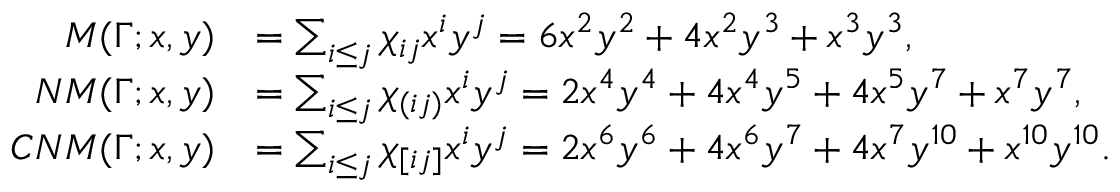<formula> <loc_0><loc_0><loc_500><loc_500>\begin{array} { r l } { M ( \Gamma ; x , y ) } & { = \sum _ { i \leq j } \chi _ { i j } x ^ { i } y ^ { j } = 6 x ^ { 2 } y ^ { 2 } + 4 x ^ { 2 } y ^ { 3 } + x ^ { 3 } y ^ { 3 } , } \\ { N M ( \Gamma ; x , y ) } & { = \sum _ { i \leq j } \chi _ { ( i j ) } x ^ { i } y ^ { j } = 2 x ^ { 4 } y ^ { 4 } + 4 x ^ { 4 } y ^ { 5 } + 4 x ^ { 5 } y ^ { 7 } + x ^ { 7 } y ^ { 7 } , } \\ { C N M ( \Gamma ; x , y ) } & { = \sum _ { i \leq j } \chi _ { [ i j ] } x ^ { i } y ^ { j } = 2 x ^ { 6 } y ^ { 6 } + 4 x ^ { 6 } y ^ { 7 } + 4 x ^ { 7 } y ^ { 1 0 } + x ^ { 1 0 } y ^ { 1 0 } . } \end{array}</formula> 